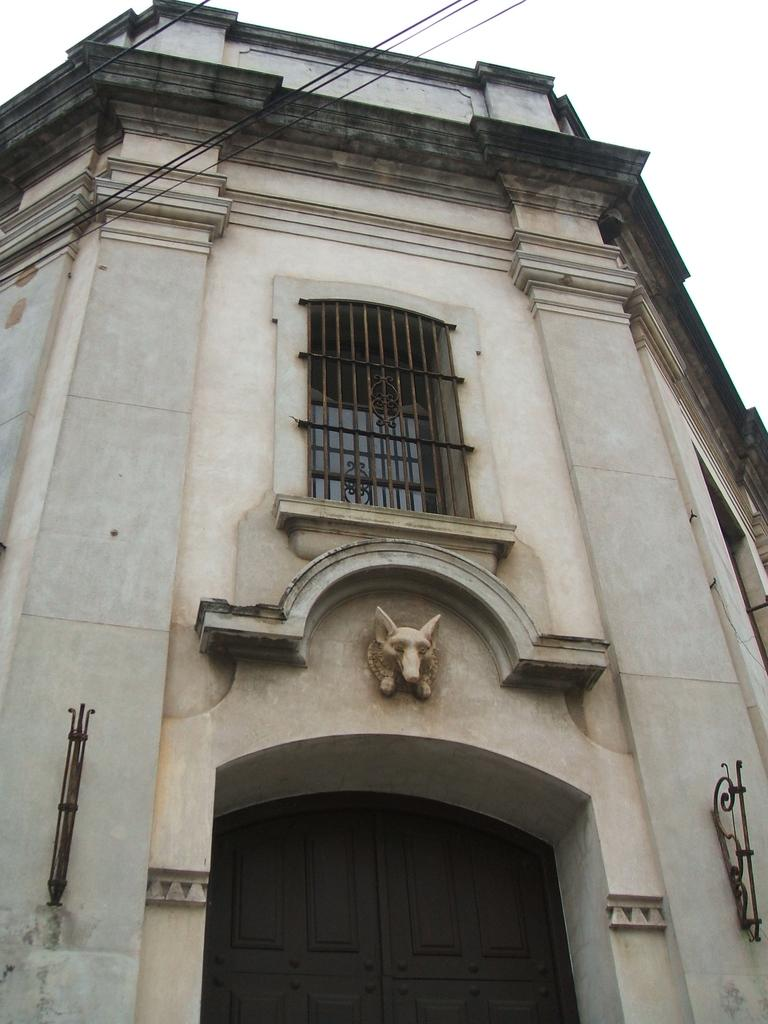What type of structure can be seen in the image? There is a building in the image. What architectural feature is present in the image? There is a wall in the image. What type of window is visible in the image? There is a glass window in the image. What type of barrier is present in the image? There is a grille in the image. What type of entrance is visible in the image? There is a door in the image. What type of artwork is present in the image? There is a sculpture in the image. What type of objects can be seen in the image? There are objects in the image. What is visible at the top of the image? The sky is visible at the top of the image, and there are wires visible as well. What type of dinner is being served in the image? There is no dinner present in the image; it features a building with various architectural elements and a sculpture. Is there a fire visible in the image? No, there is no fire present in the image. What color is the crayon used to draw on the wall in the image? There is no crayon or drawing present on the wall in the image. 